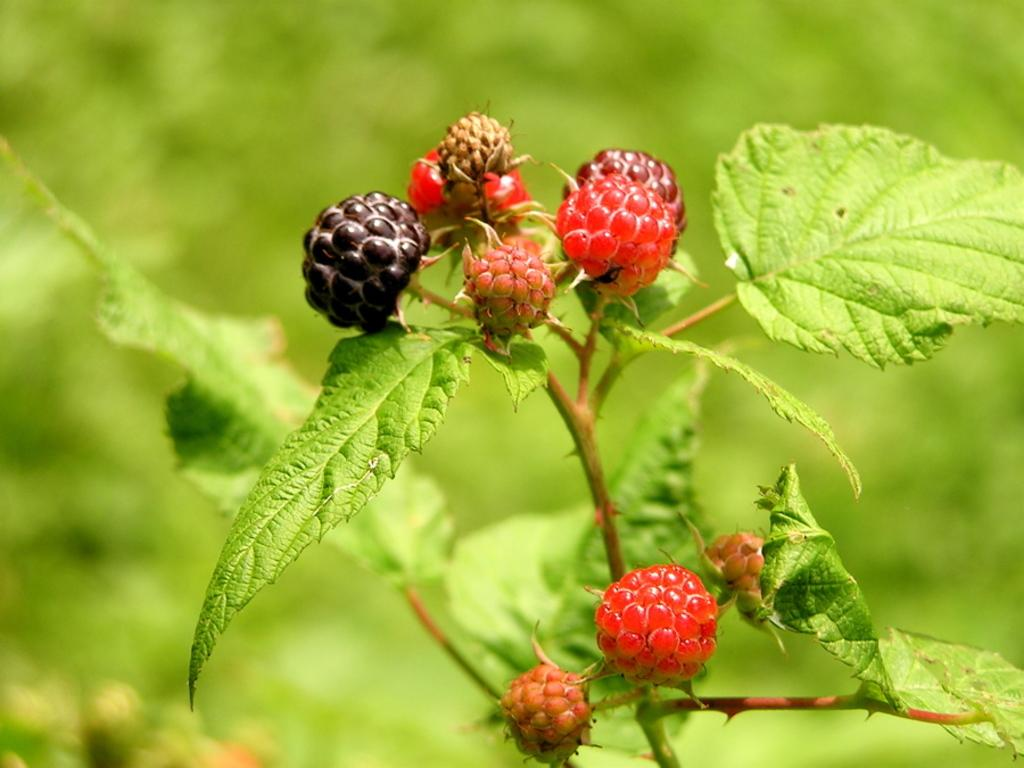What type of food can be seen in the image? There are fruits in the image. What colors are the fruits? The fruits have red and black colors. What else is present in the image besides the fruits? There are plants in the image. What color are the plants? The plants have green colors. What type of quilt is being used to cover the fruits in the image? There is no quilt present in the image; it features fruits and plants. 